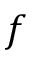Convert formula to latex. <formula><loc_0><loc_0><loc_500><loc_500>f</formula> 